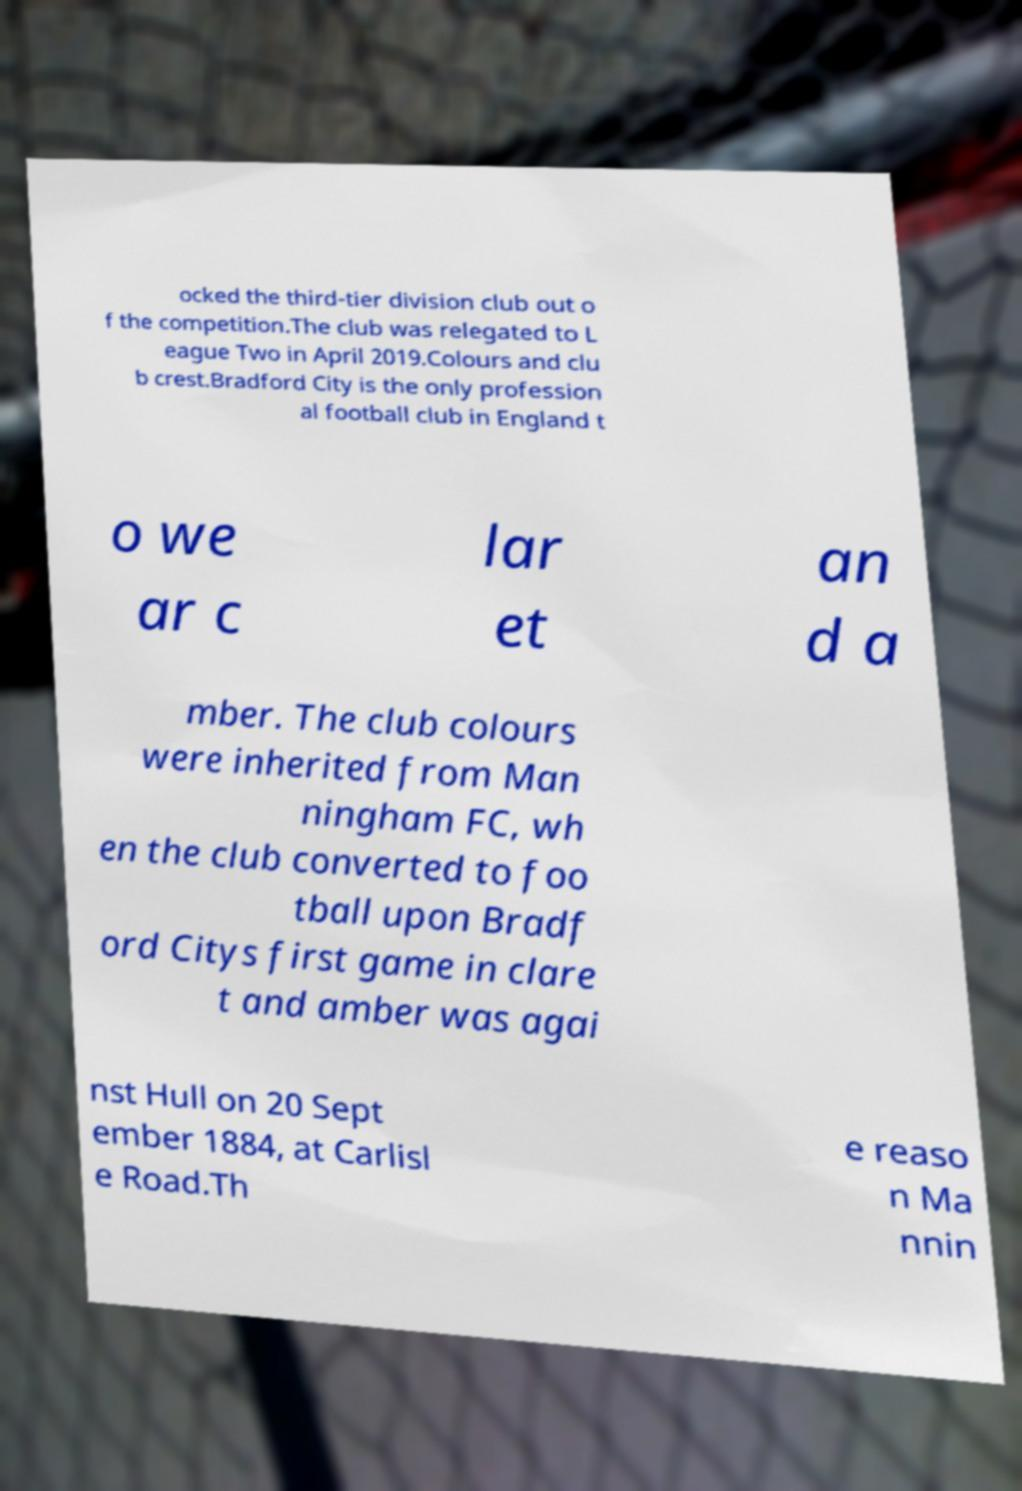There's text embedded in this image that I need extracted. Can you transcribe it verbatim? ocked the third-tier division club out o f the competition.The club was relegated to L eague Two in April 2019.Colours and clu b crest.Bradford City is the only profession al football club in England t o we ar c lar et an d a mber. The club colours were inherited from Man ningham FC, wh en the club converted to foo tball upon Bradf ord Citys first game in clare t and amber was agai nst Hull on 20 Sept ember 1884, at Carlisl e Road.Th e reaso n Ma nnin 